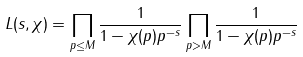<formula> <loc_0><loc_0><loc_500><loc_500>L ( s , \chi ) = \prod _ { p \leq M } \frac { 1 } { 1 - \chi ( p ) p ^ { - s } } \prod _ { p > M } \frac { 1 } { 1 - \chi ( p ) p ^ { - s } }</formula> 